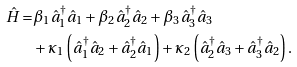<formula> <loc_0><loc_0><loc_500><loc_500>\hat { H } = & \beta _ { 1 } \hat { a } ^ { \dagger } _ { 1 } \hat { a } _ { 1 } + \beta _ { 2 } \hat { a } ^ { \dagger } _ { 2 } \hat { a } _ { 2 } + \beta _ { 3 } \hat { a } ^ { \dagger } _ { 3 } \hat { a } _ { 3 } \\ & + \kappa _ { 1 } \left ( \hat { a } ^ { \dagger } _ { 1 } \hat { a } _ { 2 } + \hat { a } ^ { \dagger } _ { 2 } \hat { a } _ { 1 } \right ) + \kappa _ { 2 } \left ( \hat { a } ^ { \dagger } _ { 2 } \hat { a } _ { 3 } + \hat { a } ^ { \dagger } _ { 3 } \hat { a } _ { 2 } \right ) .</formula> 